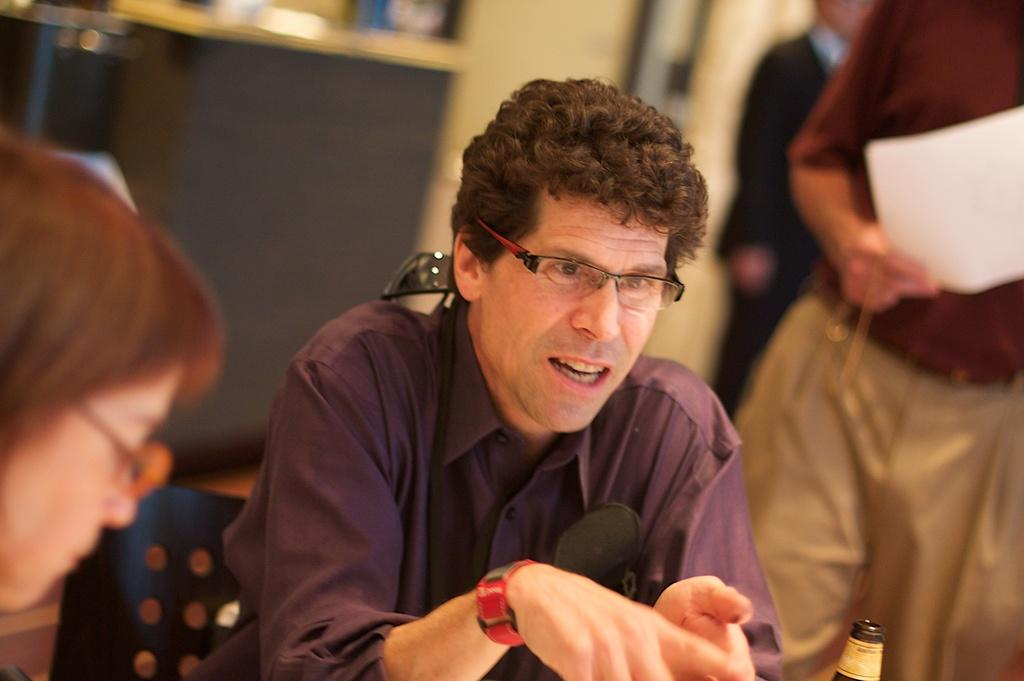How many people are in the image? There is a group of people in the image, but the exact number cannot be determined from the provided facts. What type of furniture is visible in the image? Chairs and a table are visible in the image. What is the background of the image made of? There is a wall in the image, which suggests that the background is made of a solid material. What type of decorations are present in the image? There are photo frames in the image, which may be used for displaying pictures or artwork. What type of location might the image have been taken in? The image may have been taken in a hall, based on the presence of chairs, a table, and a group of people. What type of jail is visible in the image? There is no jail present in the image; it features a group of people, chairs, a table, a wall, and photo frames. What type of discussion is taking place among the people in the image? There is no indication of a discussion taking place among the people in the image, as their expressions and body language cannot be determined from the provided facts. 